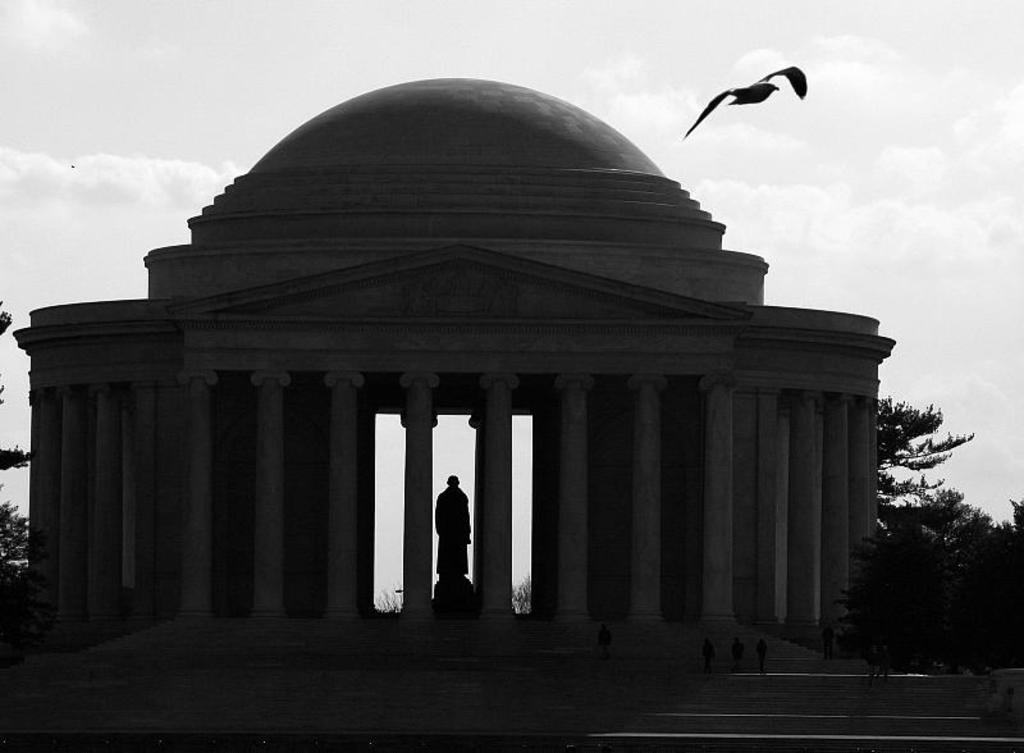What is the main structure featured in the image? There is the Thomas Jefferson Memorial in the image. What can be seen on both sides of the memorial? There are trees on either side of the memorial. Are there any people present in the image? Yes, there are people in front of the memorial. What else can be seen in the sky in the image? There is a bird flying in the air in the image. What type of produce is being sold by the lawyer in the image? There is no lawyer or produce present in the image; it features the Thomas Jefferson Memorial with trees, people, and a bird. 